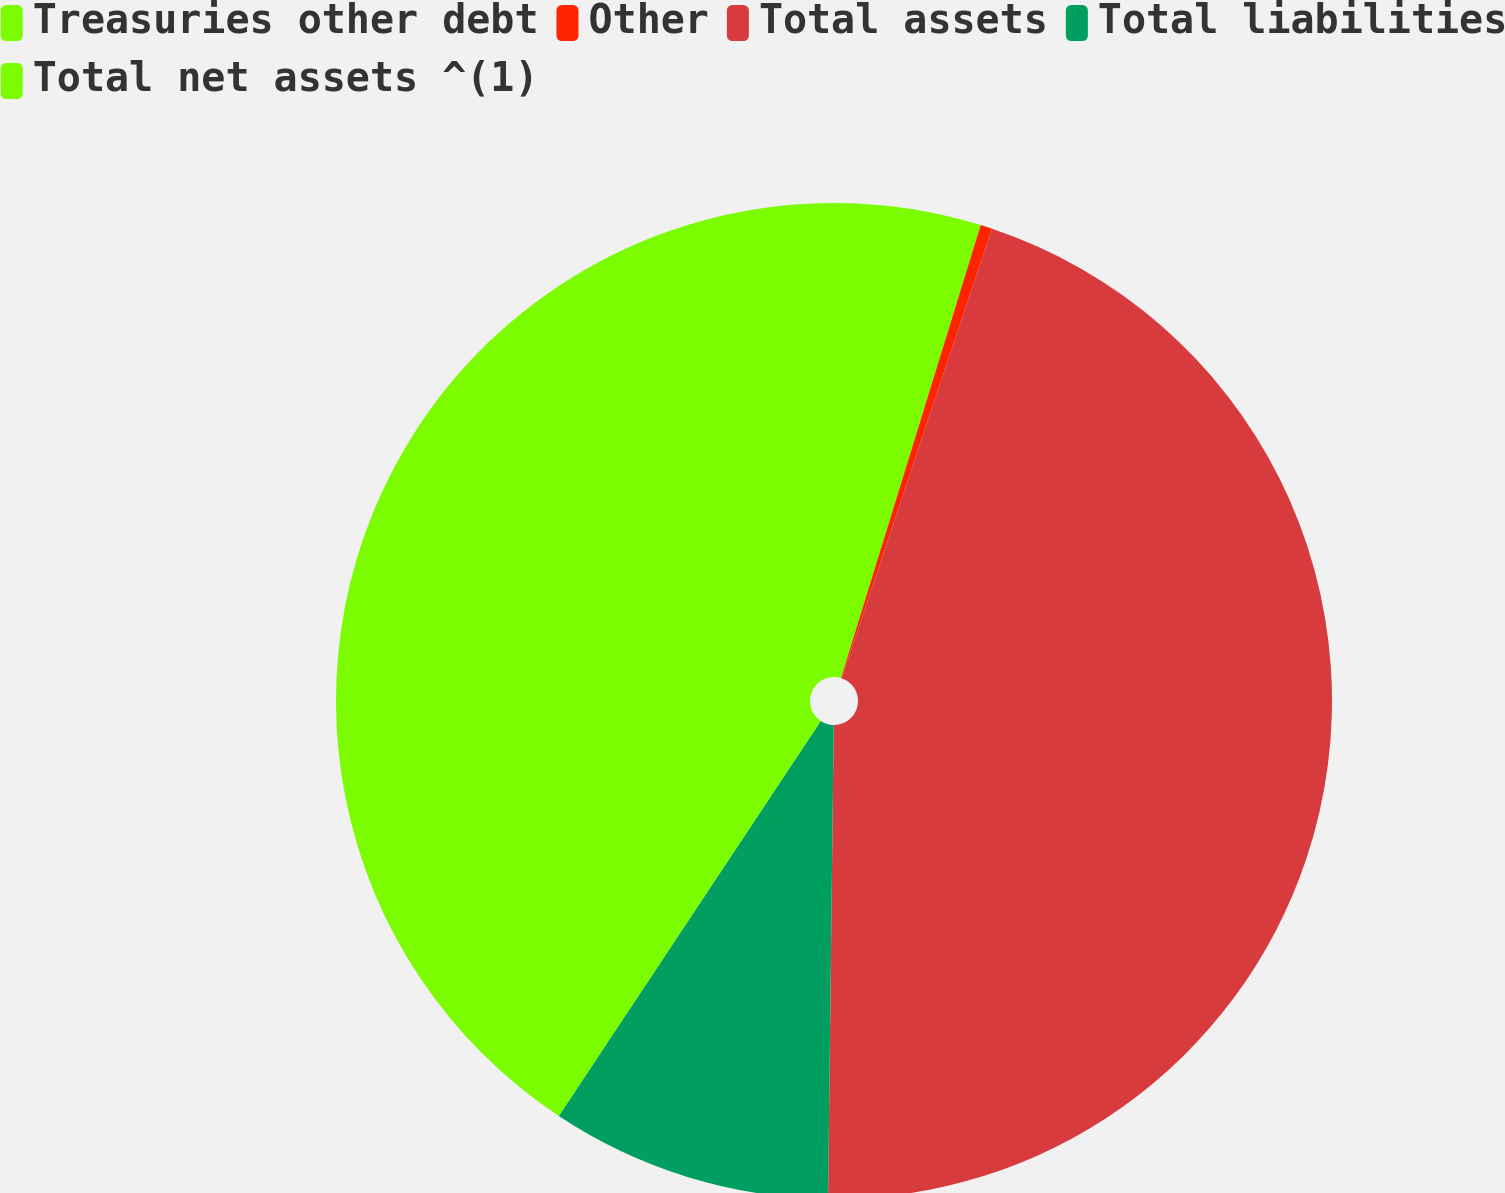Convert chart to OTSL. <chart><loc_0><loc_0><loc_500><loc_500><pie_chart><fcel>Treasuries other debt<fcel>Other<fcel>Total assets<fcel>Total liabilities<fcel>Total net assets ^(1)<nl><fcel>4.76%<fcel>0.38%<fcel>45.05%<fcel>9.13%<fcel>40.68%<nl></chart> 